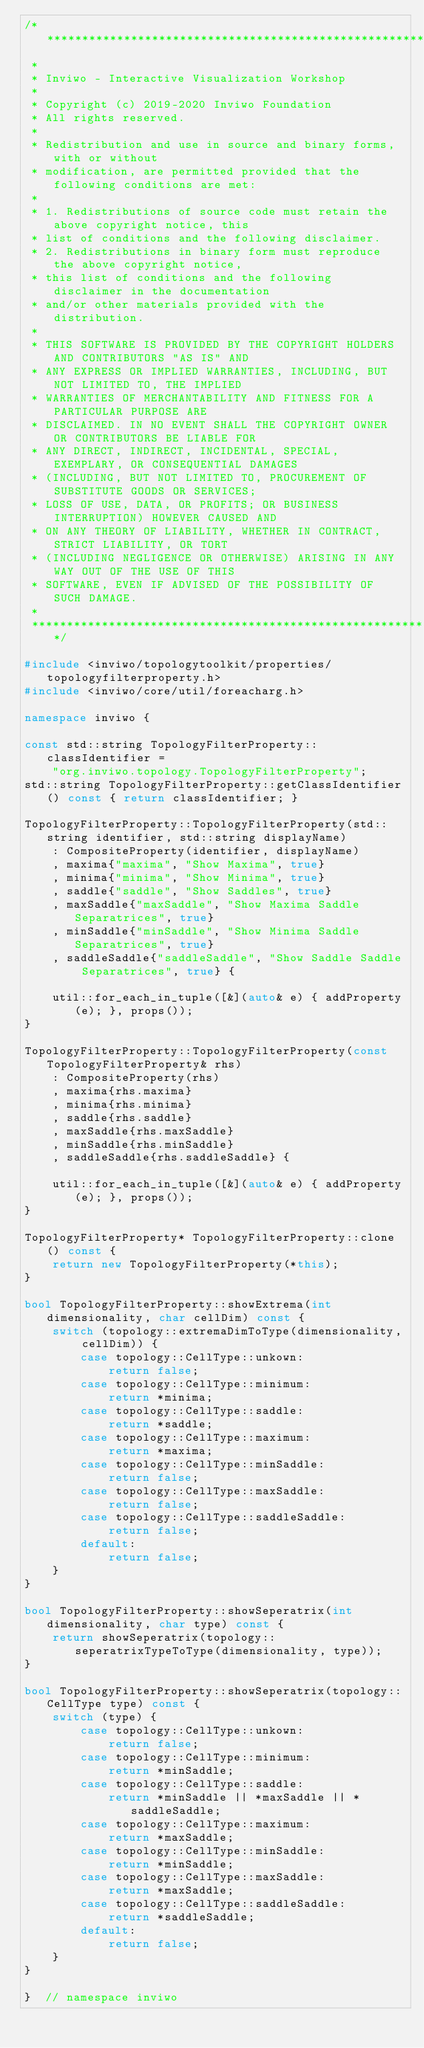Convert code to text. <code><loc_0><loc_0><loc_500><loc_500><_C++_>/*********************************************************************************
 *
 * Inviwo - Interactive Visualization Workshop
 *
 * Copyright (c) 2019-2020 Inviwo Foundation
 * All rights reserved.
 *
 * Redistribution and use in source and binary forms, with or without
 * modification, are permitted provided that the following conditions are met:
 *
 * 1. Redistributions of source code must retain the above copyright notice, this
 * list of conditions and the following disclaimer.
 * 2. Redistributions in binary form must reproduce the above copyright notice,
 * this list of conditions and the following disclaimer in the documentation
 * and/or other materials provided with the distribution.
 *
 * THIS SOFTWARE IS PROVIDED BY THE COPYRIGHT HOLDERS AND CONTRIBUTORS "AS IS" AND
 * ANY EXPRESS OR IMPLIED WARRANTIES, INCLUDING, BUT NOT LIMITED TO, THE IMPLIED
 * WARRANTIES OF MERCHANTABILITY AND FITNESS FOR A PARTICULAR PURPOSE ARE
 * DISCLAIMED. IN NO EVENT SHALL THE COPYRIGHT OWNER OR CONTRIBUTORS BE LIABLE FOR
 * ANY DIRECT, INDIRECT, INCIDENTAL, SPECIAL, EXEMPLARY, OR CONSEQUENTIAL DAMAGES
 * (INCLUDING, BUT NOT LIMITED TO, PROCUREMENT OF SUBSTITUTE GOODS OR SERVICES;
 * LOSS OF USE, DATA, OR PROFITS; OR BUSINESS INTERRUPTION) HOWEVER CAUSED AND
 * ON ANY THEORY OF LIABILITY, WHETHER IN CONTRACT, STRICT LIABILITY, OR TORT
 * (INCLUDING NEGLIGENCE OR OTHERWISE) ARISING IN ANY WAY OUT OF THE USE OF THIS
 * SOFTWARE, EVEN IF ADVISED OF THE POSSIBILITY OF SUCH DAMAGE.
 *
 *********************************************************************************/

#include <inviwo/topologytoolkit/properties/topologyfilterproperty.h>
#include <inviwo/core/util/foreacharg.h>

namespace inviwo {

const std::string TopologyFilterProperty::classIdentifier =
    "org.inviwo.topology.TopologyFilterProperty";
std::string TopologyFilterProperty::getClassIdentifier() const { return classIdentifier; }

TopologyFilterProperty::TopologyFilterProperty(std::string identifier, std::string displayName)
    : CompositeProperty(identifier, displayName)
    , maxima{"maxima", "Show Maxima", true}
    , minima{"minima", "Show Minima", true}
    , saddle{"saddle", "Show Saddles", true}
    , maxSaddle{"maxSaddle", "Show Maxima Saddle Separatrices", true}
    , minSaddle{"minSaddle", "Show Minima Saddle Separatrices", true}
    , saddleSaddle{"saddleSaddle", "Show Saddle Saddle Separatrices", true} {

    util::for_each_in_tuple([&](auto& e) { addProperty(e); }, props());
}

TopologyFilterProperty::TopologyFilterProperty(const TopologyFilterProperty& rhs)
    : CompositeProperty(rhs)
    , maxima{rhs.maxima}
    , minima{rhs.minima}
    , saddle{rhs.saddle}
    , maxSaddle{rhs.maxSaddle}
    , minSaddle{rhs.minSaddle}
    , saddleSaddle{rhs.saddleSaddle} {

    util::for_each_in_tuple([&](auto& e) { addProperty(e); }, props());
}

TopologyFilterProperty* TopologyFilterProperty::clone() const {
    return new TopologyFilterProperty(*this);
}

bool TopologyFilterProperty::showExtrema(int dimensionality, char cellDim) const {
    switch (topology::extremaDimToType(dimensionality, cellDim)) {
        case topology::CellType::unkown:
            return false;
        case topology::CellType::minimum:
            return *minima;
        case topology::CellType::saddle:
            return *saddle;
        case topology::CellType::maximum:
            return *maxima;
        case topology::CellType::minSaddle:
            return false;
        case topology::CellType::maxSaddle:
            return false;
        case topology::CellType::saddleSaddle:
            return false;
        default:
            return false;
    }
}

bool TopologyFilterProperty::showSeperatrix(int dimensionality, char type) const {
    return showSeperatrix(topology::seperatrixTypeToType(dimensionality, type));
}

bool TopologyFilterProperty::showSeperatrix(topology::CellType type) const {
    switch (type) {
        case topology::CellType::unkown:
            return false;
        case topology::CellType::minimum:
            return *minSaddle;
        case topology::CellType::saddle:
            return *minSaddle || *maxSaddle || *saddleSaddle;
        case topology::CellType::maximum:
            return *maxSaddle;
        case topology::CellType::minSaddle:
            return *minSaddle;
        case topology::CellType::maxSaddle:
            return *maxSaddle;
        case topology::CellType::saddleSaddle:
            return *saddleSaddle;
        default:
            return false;
    }
}

}  // namespace inviwo
</code> 